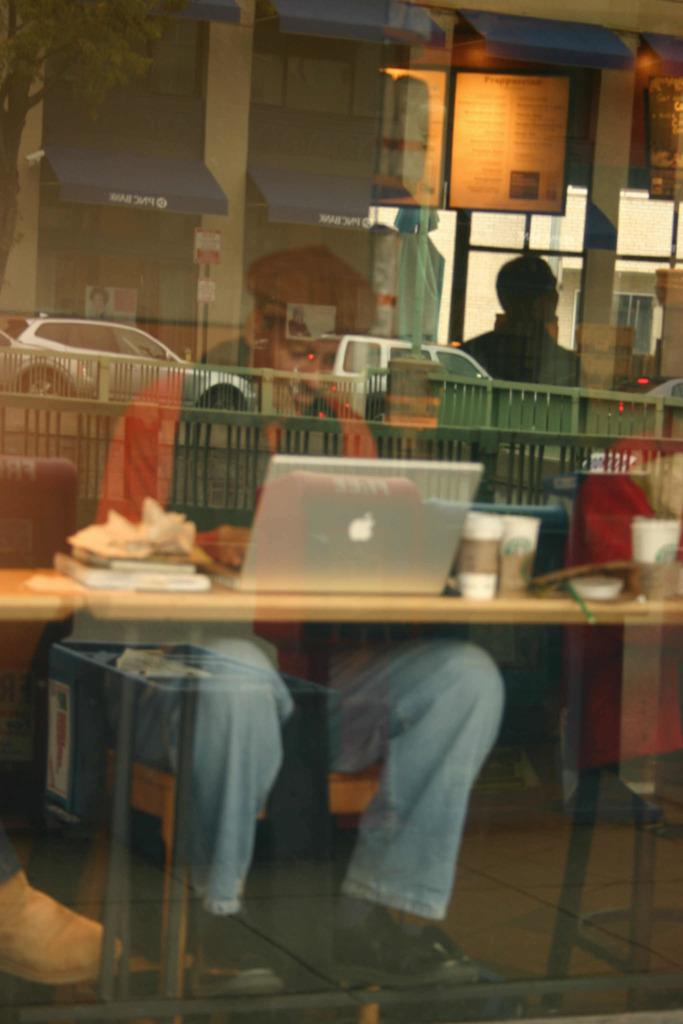What piece of furniture is in the image? There is a table in the image. What electronic device is on the table? A laptop is present on the table. What type of dishware is on the table? Glasses are on the table. What is the person in the image doing? There is a person sitting on a chair in front of the table. What type of barrier is visible in the image? There is fencing visible in the image. What type of vehicles are present in the image? Cars are present in the image. What type of structures are in the background of the image? There are buildings in the background. What type of plant is located at the left side of the image? A tree is located at the left side of the image. Where is the market located in the image? There is no market present in the image. How many quarters are visible in the image? There are no quarters present in the image. 